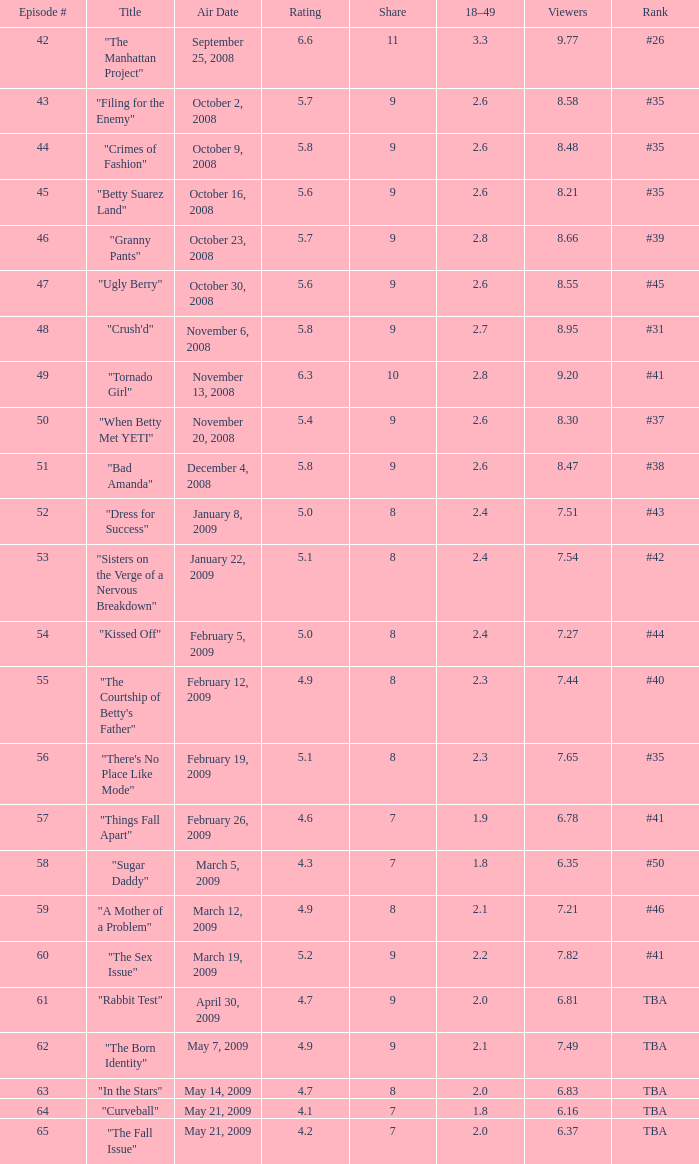What is the total number of Viewers when the rank is #40? 1.0. 